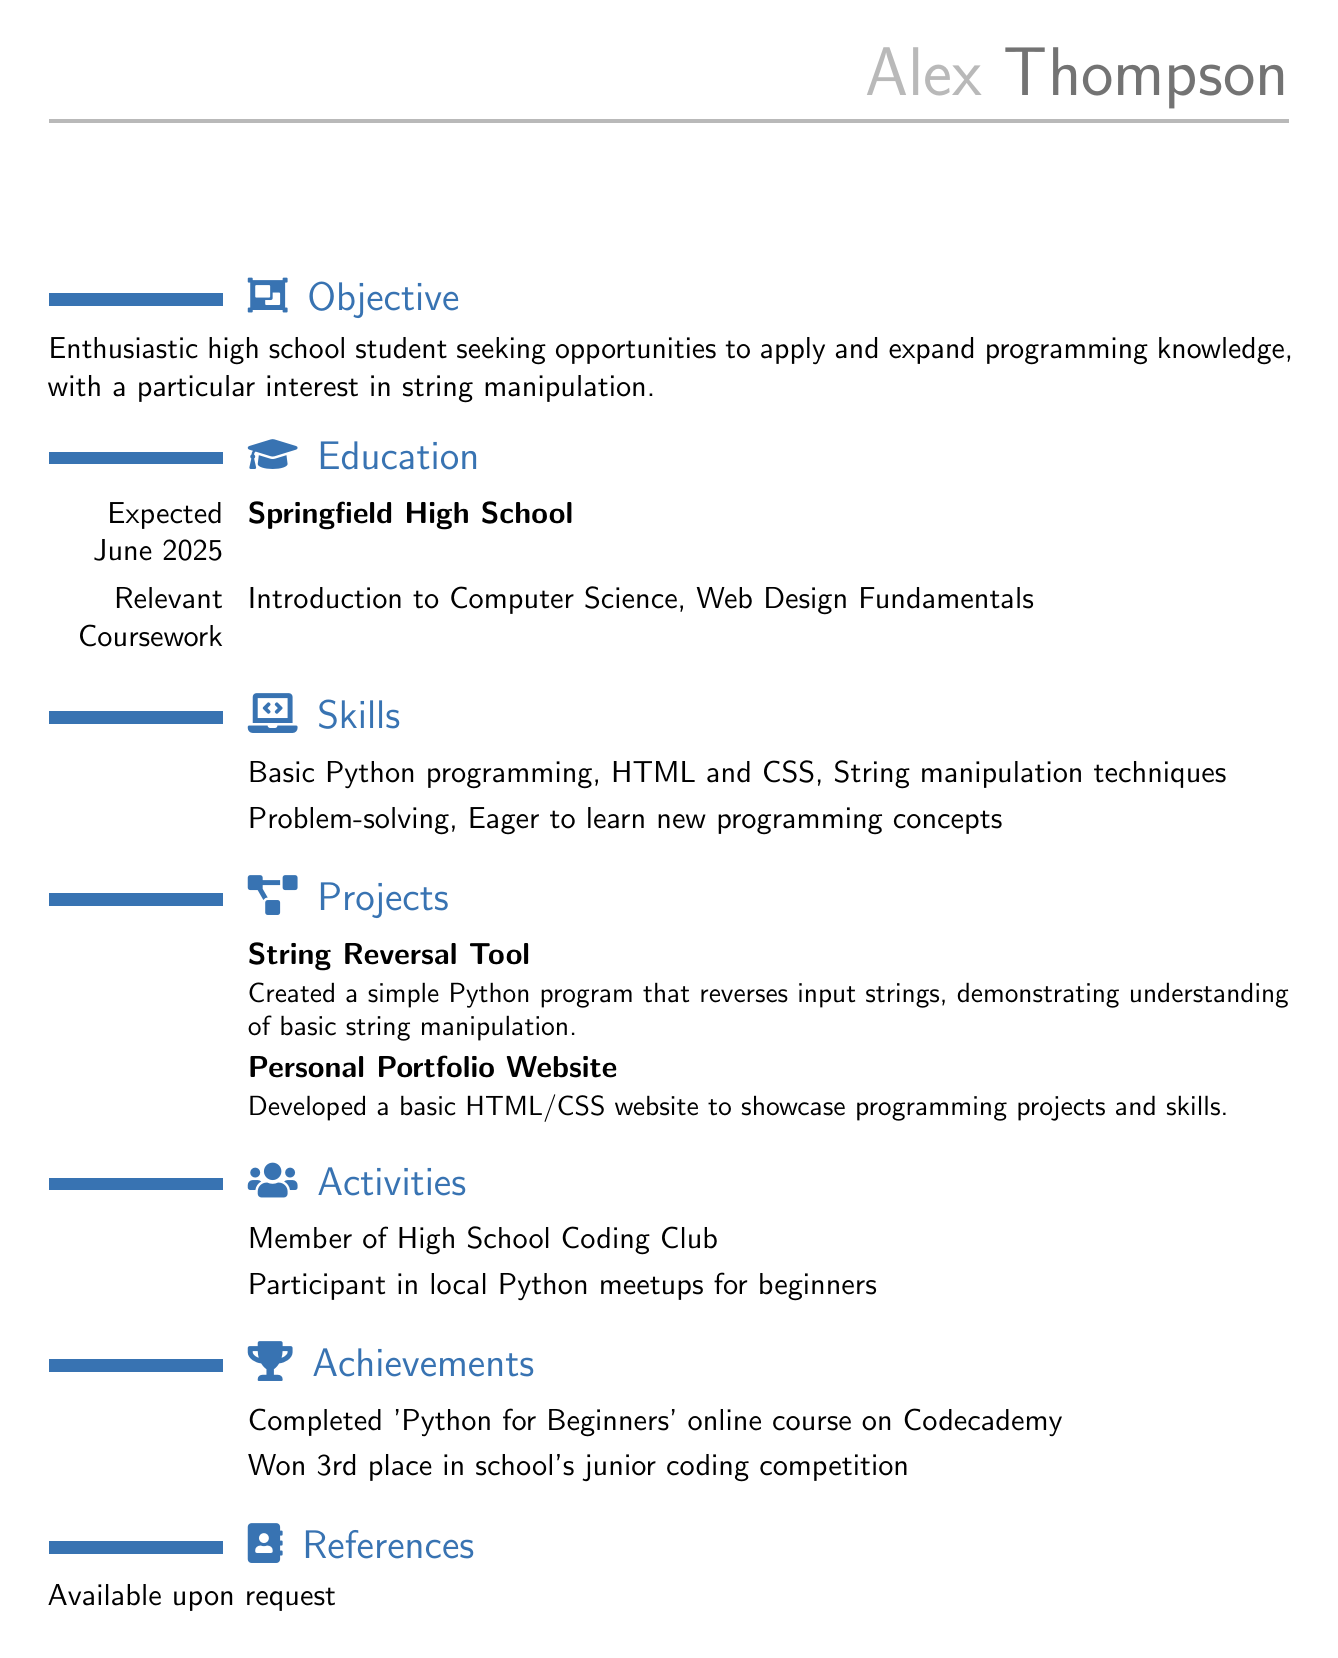What is the name of the individual? The name is listed at the top of the CV under personal information.
Answer: Alex Thompson What is the expected graduation date? The expected graduation date is mentioned in the education section of the document.
Answer: June 2025 What programming language does Alex have basic knowledge of? The skills section of the CV explicitly mentions the programming language Alex is familiar with.
Answer: Python What project demonstrates understanding of string manipulation? The projects section lists projects, including one focused on string manipulation.
Answer: String Reversal Tool How many places did Alex win in the coding competition? The achievements section highlights Alex's performance in the competition.
Answer: 3rd place Which online course did Alex complete? The achievements section mentions the specific course Alex completed related to programming.
Answer: Python for Beginners What is one of Alex's interests listed in the objective? The objective section states Alex's focus and interests in programming.
Answer: String manipulation How many relevant coursework subjects are listed? The education section specifies the number of coursework subjects that are relevant to Alex's programming skills.
Answer: 2 What type of website did Alex develop? The projects section describes the nature of the website that Alex created.
Answer: Personal Portfolio Website Where does Alex reside? The location is included in the personal information section of the CV.
Answer: Springfield, IL 